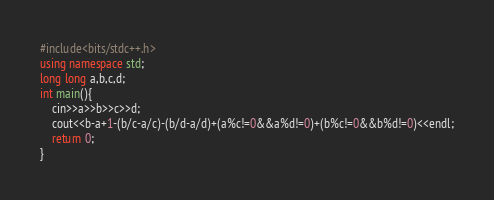<code> <loc_0><loc_0><loc_500><loc_500><_C++_>#include<bits/stdc++.h>
using namespace std;
long long a,b,c,d;
int main(){
	cin>>a>>b>>c>>d;
	cout<<b-a+1-(b/c-a/c)-(b/d-a/d)+(a%c!=0&&a%d!=0)+(b%c!=0&&b%d!=0)<<endl;
	return 0;
}</code> 